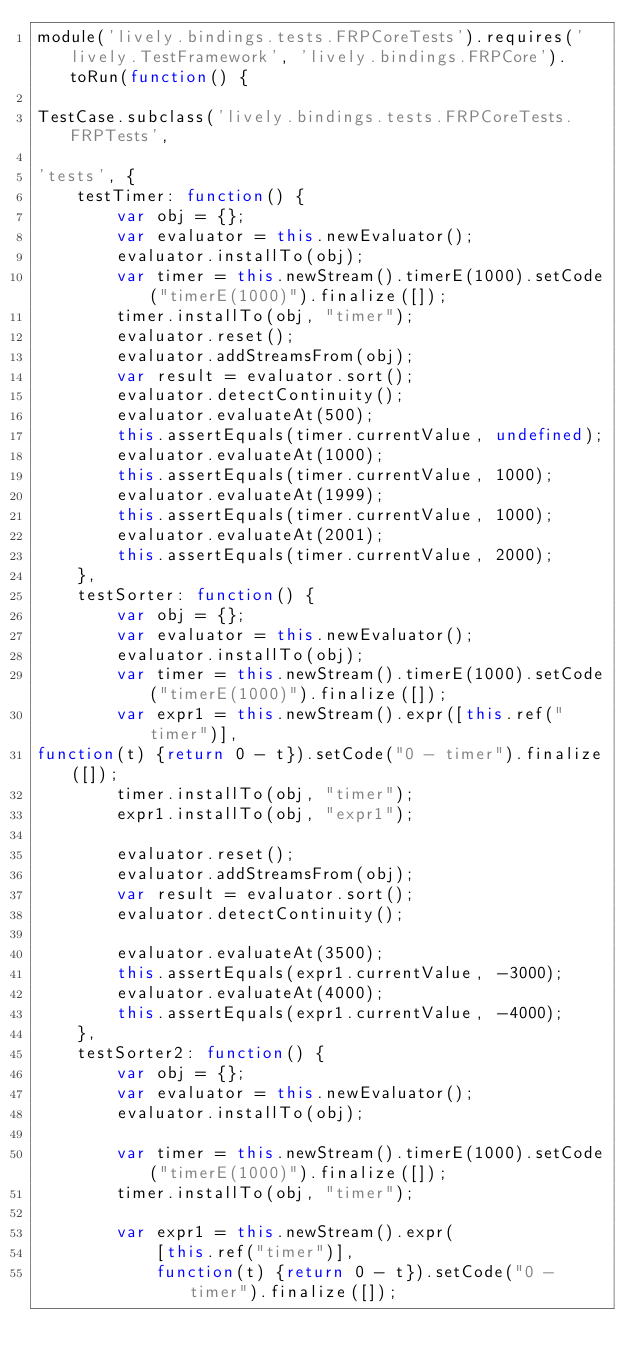Convert code to text. <code><loc_0><loc_0><loc_500><loc_500><_JavaScript_>module('lively.bindings.tests.FRPCoreTests').requires('lively.TestFramework', 'lively.bindings.FRPCore').toRun(function() {

TestCase.subclass('lively.bindings.tests.FRPCoreTests.FRPTests',

'tests', {
    testTimer: function() {
        var obj = {};
        var evaluator = this.newEvaluator();
        evaluator.installTo(obj);
        var timer = this.newStream().timerE(1000).setCode("timerE(1000)").finalize([]);
        timer.installTo(obj, "timer");
        evaluator.reset();
        evaluator.addStreamsFrom(obj);
        var result = evaluator.sort();
        evaluator.detectContinuity();
        evaluator.evaluateAt(500);
        this.assertEquals(timer.currentValue, undefined);
        evaluator.evaluateAt(1000);
        this.assertEquals(timer.currentValue, 1000);
        evaluator.evaluateAt(1999);
        this.assertEquals(timer.currentValue, 1000);
        evaluator.evaluateAt(2001);
        this.assertEquals(timer.currentValue, 2000);
    },
    testSorter: function() {
        var obj = {};
        var evaluator = this.newEvaluator();
        evaluator.installTo(obj);
        var timer = this.newStream().timerE(1000).setCode("timerE(1000)").finalize([]);
        var expr1 = this.newStream().expr([this.ref("timer")],
function(t) {return 0 - t}).setCode("0 - timer").finalize([]);
        timer.installTo(obj, "timer");
        expr1.installTo(obj, "expr1");

        evaluator.reset();
        evaluator.addStreamsFrom(obj);
        var result = evaluator.sort();
        evaluator.detectContinuity();

        evaluator.evaluateAt(3500);
        this.assertEquals(expr1.currentValue, -3000);
        evaluator.evaluateAt(4000);
        this.assertEquals(expr1.currentValue, -4000);
    },
    testSorter2: function() {
        var obj = {};
        var evaluator = this.newEvaluator();
        evaluator.installTo(obj);

        var timer = this.newStream().timerE(1000).setCode("timerE(1000)").finalize([]);
        timer.installTo(obj, "timer");

        var expr1 = this.newStream().expr(
            [this.ref("timer")],
            function(t) {return 0 - t}).setCode("0 - timer").finalize([]);</code> 